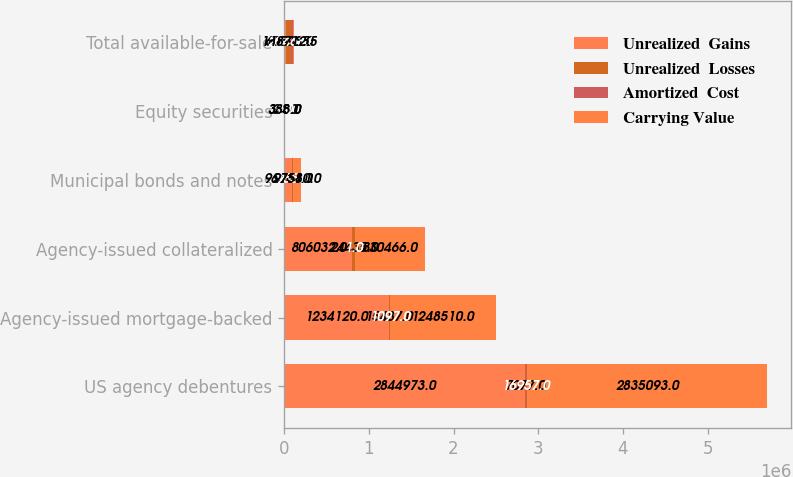Convert chart. <chart><loc_0><loc_0><loc_500><loc_500><stacked_bar_chart><ecel><fcel>US agency debentures<fcel>Agency-issued mortgage-backed<fcel>Agency-issued collateralized<fcel>Municipal bonds and notes<fcel>Equity securities<fcel>Total available-for-sale<nl><fcel>Unrealized  Gains<fcel>2.84497e+06<fcel>1.23412e+06<fcel>806032<fcel>96381<fcel>358<fcel>18712.5<nl><fcel>Unrealized  Losses<fcel>7077<fcel>15487<fcel>24435<fcel>2164<fcel>34<fcel>60593<nl><fcel>Amortized  Cost<fcel>16957<fcel>1097<fcel>1<fcel>965<fcel>9<fcel>20468<nl><fcel>Carrying Value<fcel>2.83509e+06<fcel>1.24851e+06<fcel>830466<fcel>97580<fcel>383<fcel>18712.5<nl></chart> 